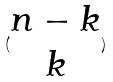Convert formula to latex. <formula><loc_0><loc_0><loc_500><loc_500>( \begin{matrix} n - k \\ k \end{matrix} )</formula> 